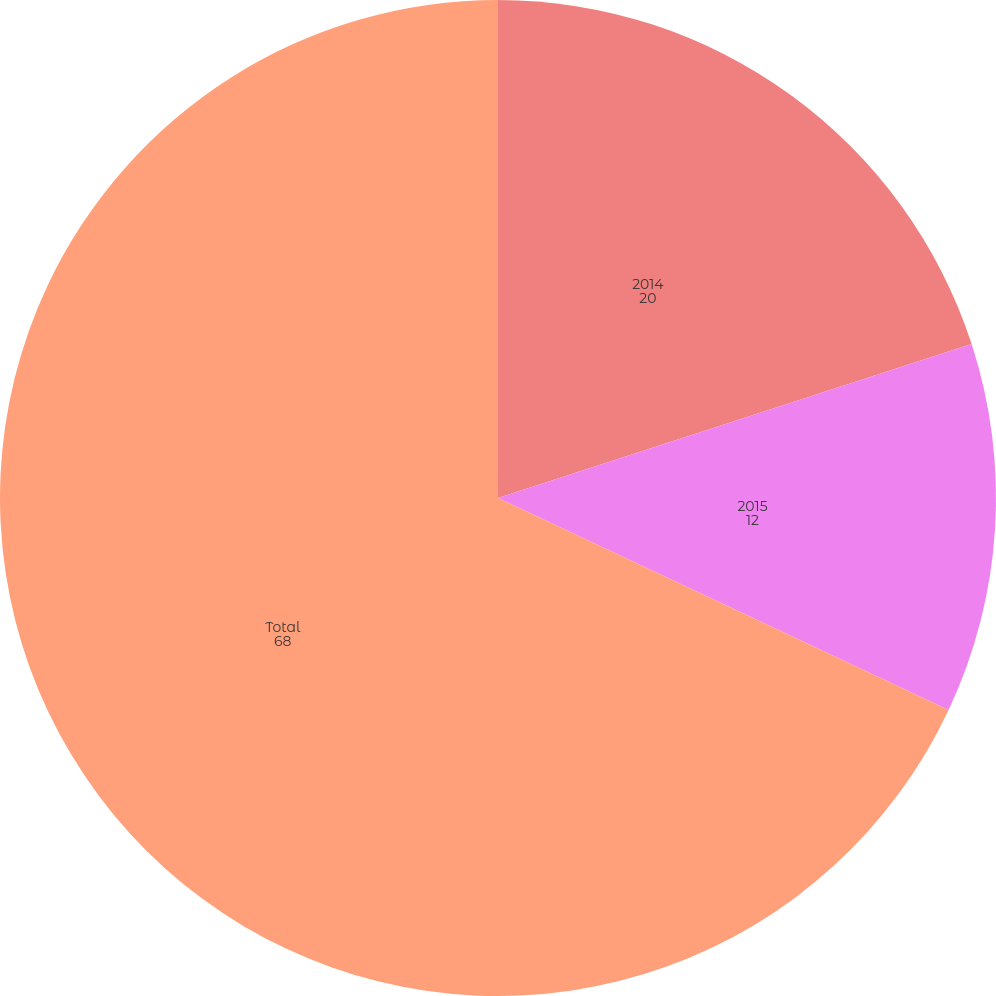Convert chart to OTSL. <chart><loc_0><loc_0><loc_500><loc_500><pie_chart><fcel>2014<fcel>2015<fcel>Total<nl><fcel>20.0%<fcel>12.0%<fcel>68.0%<nl></chart> 